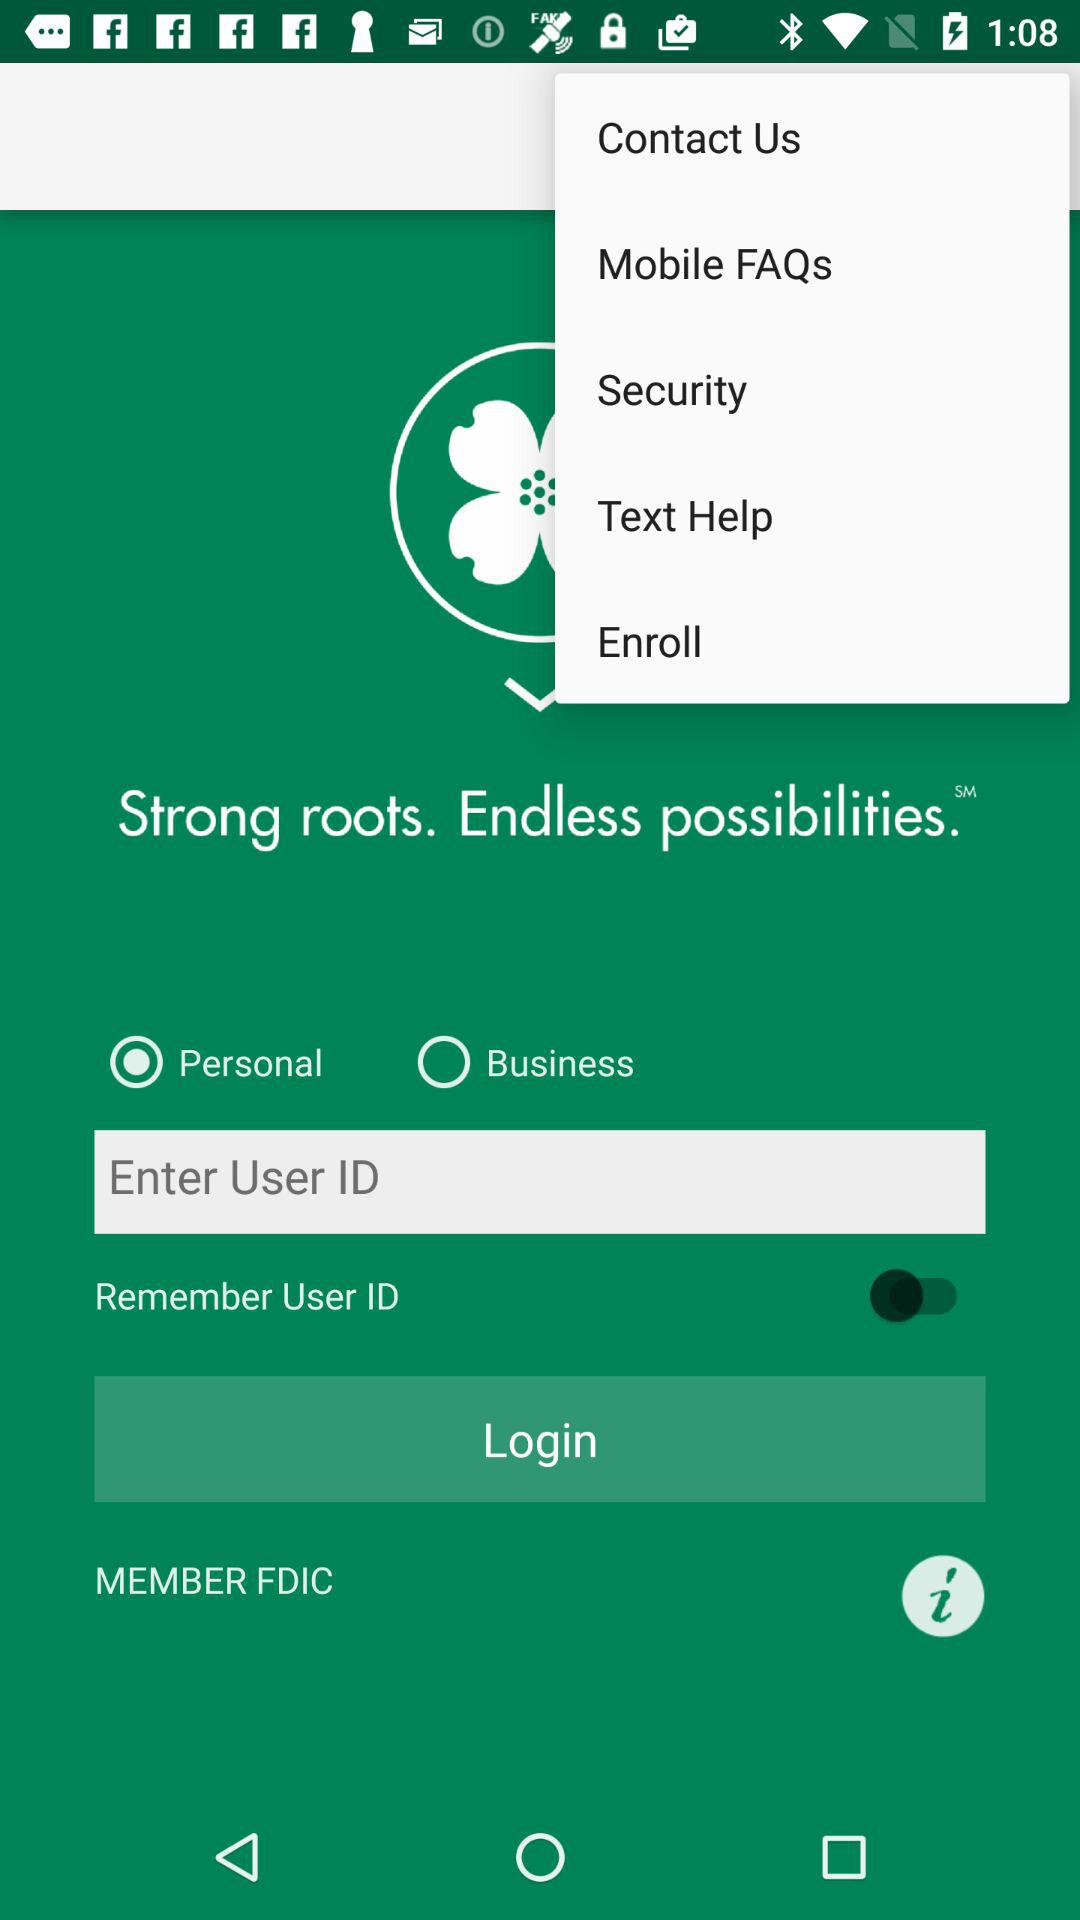What is the status of "Remember User ID"? The status is "off". 